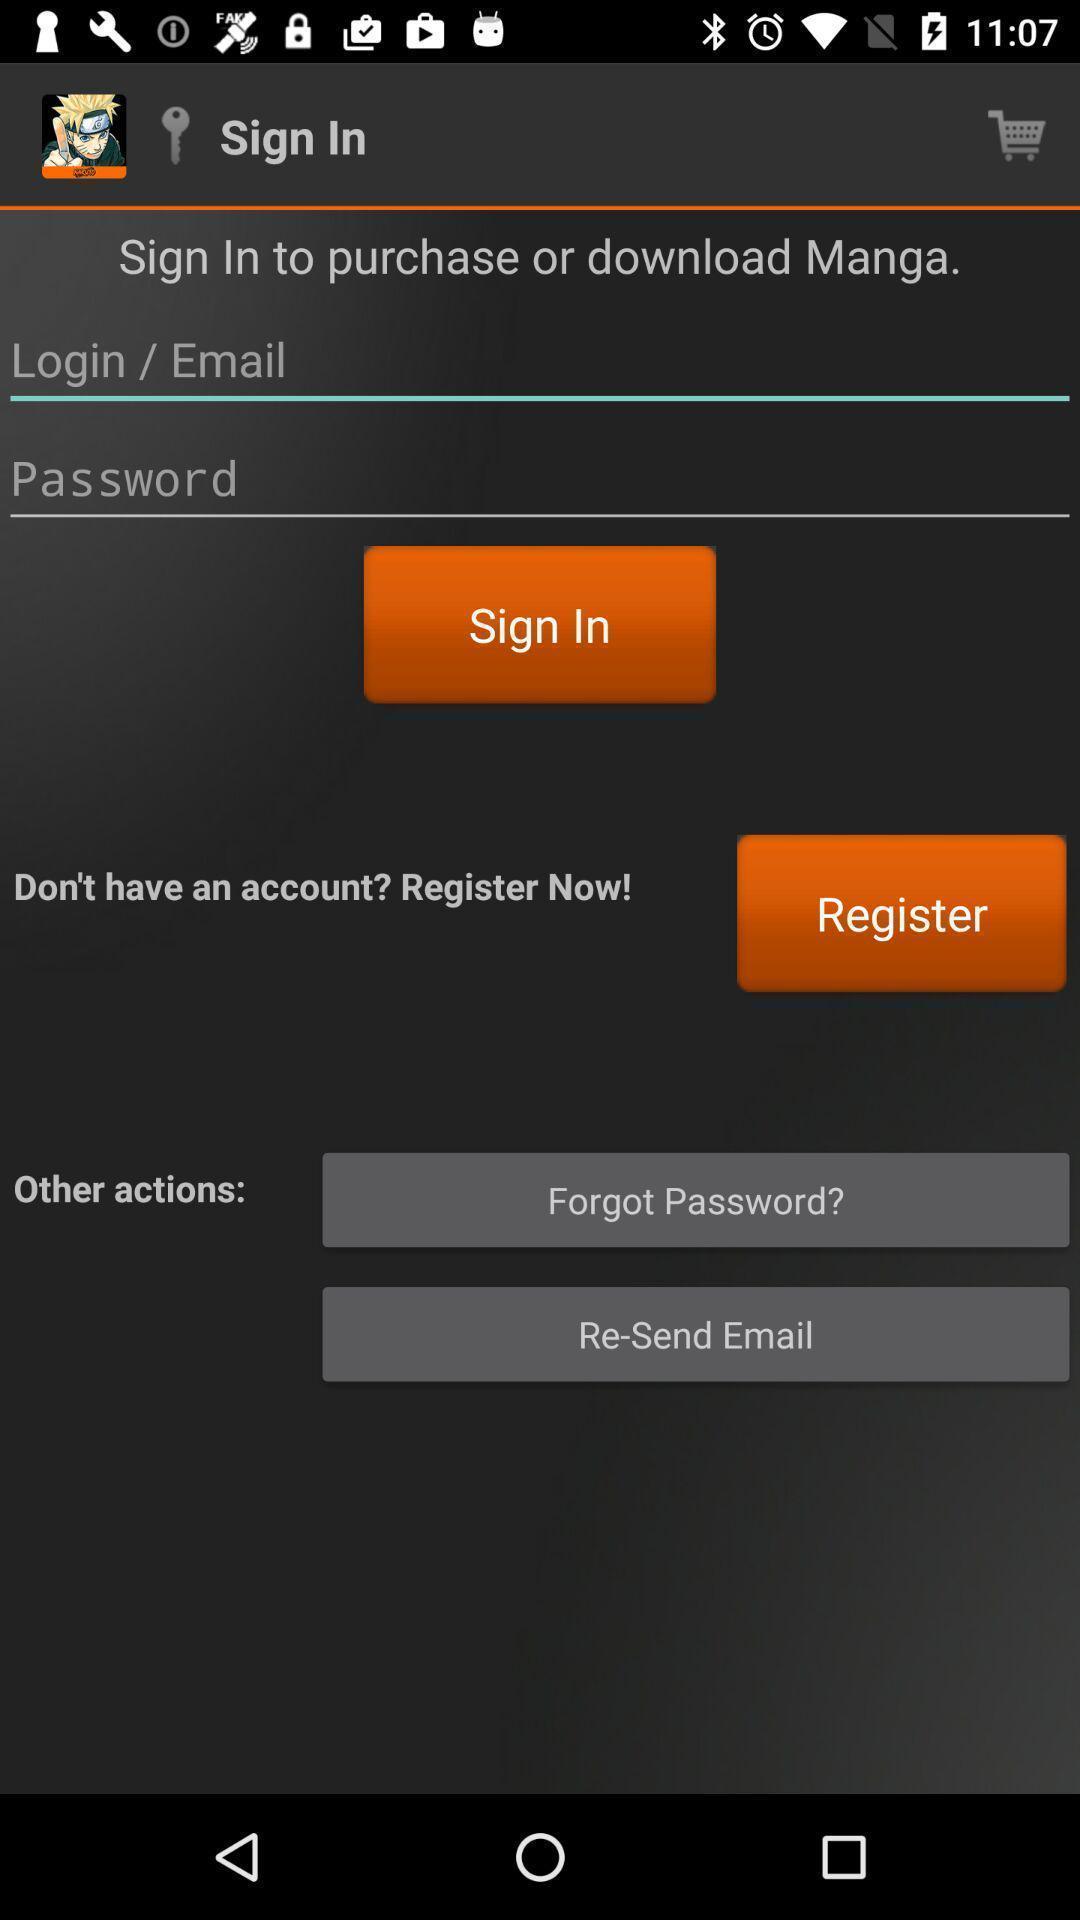Describe the key features of this screenshot. Welcome page displaying to enter details. 